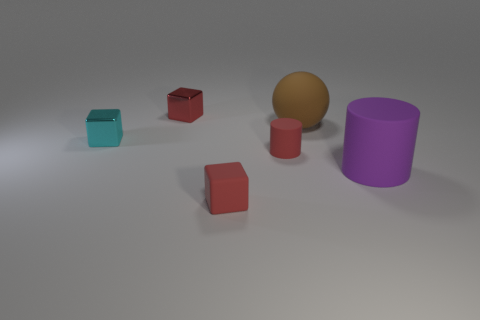Subtract all red metallic blocks. How many blocks are left? 2 Subtract all yellow balls. How many red cubes are left? 2 Add 3 tiny red blocks. How many objects exist? 9 Subtract all purple cylinders. How many cylinders are left? 1 Subtract all balls. How many objects are left? 5 Add 4 red matte cylinders. How many red matte cylinders exist? 5 Subtract 0 purple cubes. How many objects are left? 6 Subtract all green spheres. Subtract all blue cylinders. How many spheres are left? 1 Subtract all cyan spheres. Subtract all metal cubes. How many objects are left? 4 Add 4 small cyan metallic objects. How many small cyan metallic objects are left? 5 